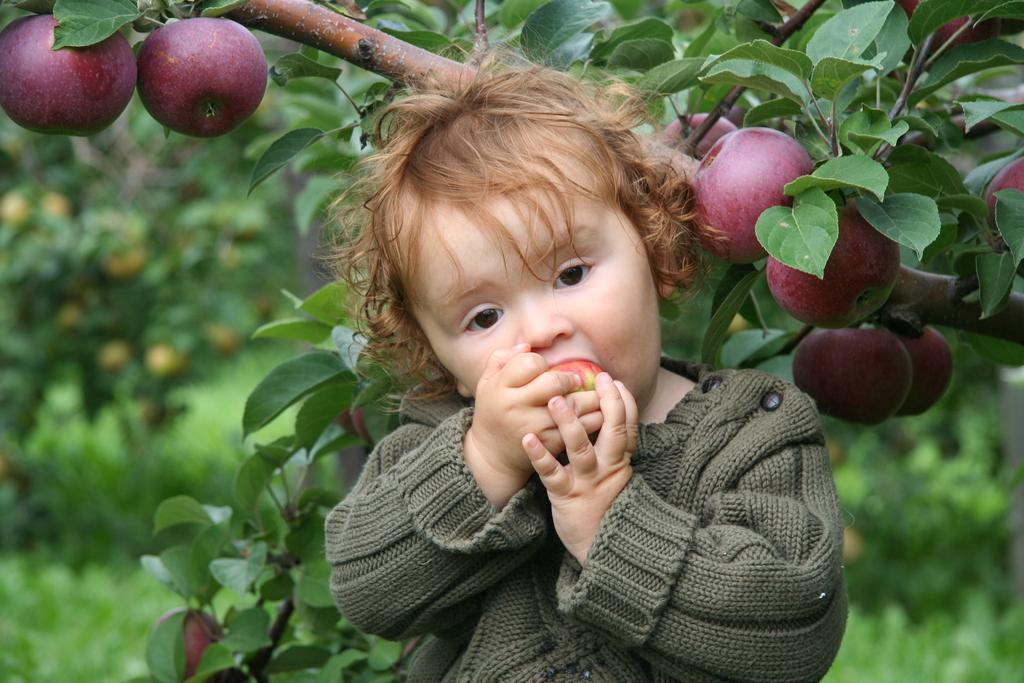Who is the main subject in the image? There is a person in the image. What is the person doing in the image? The person is eating an apple. What other food items can be seen in the image? There are fruits visible in the image. What type of vegetation is present in the image? There are green color leaves in the image. How would you describe the background of the image? The background is blurred. Can you tell me how many times the person has committed a crime in the image? There is no indication of any crime being committed in the image, as it features a person eating an apple with fruits and green leaves in the background. 